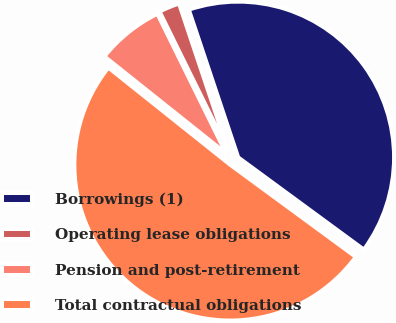Convert chart to OTSL. <chart><loc_0><loc_0><loc_500><loc_500><pie_chart><fcel>Borrowings (1)<fcel>Operating lease obligations<fcel>Pension and post-retirement<fcel>Total contractual obligations<nl><fcel>40.21%<fcel>2.15%<fcel>7.0%<fcel>50.64%<nl></chart> 